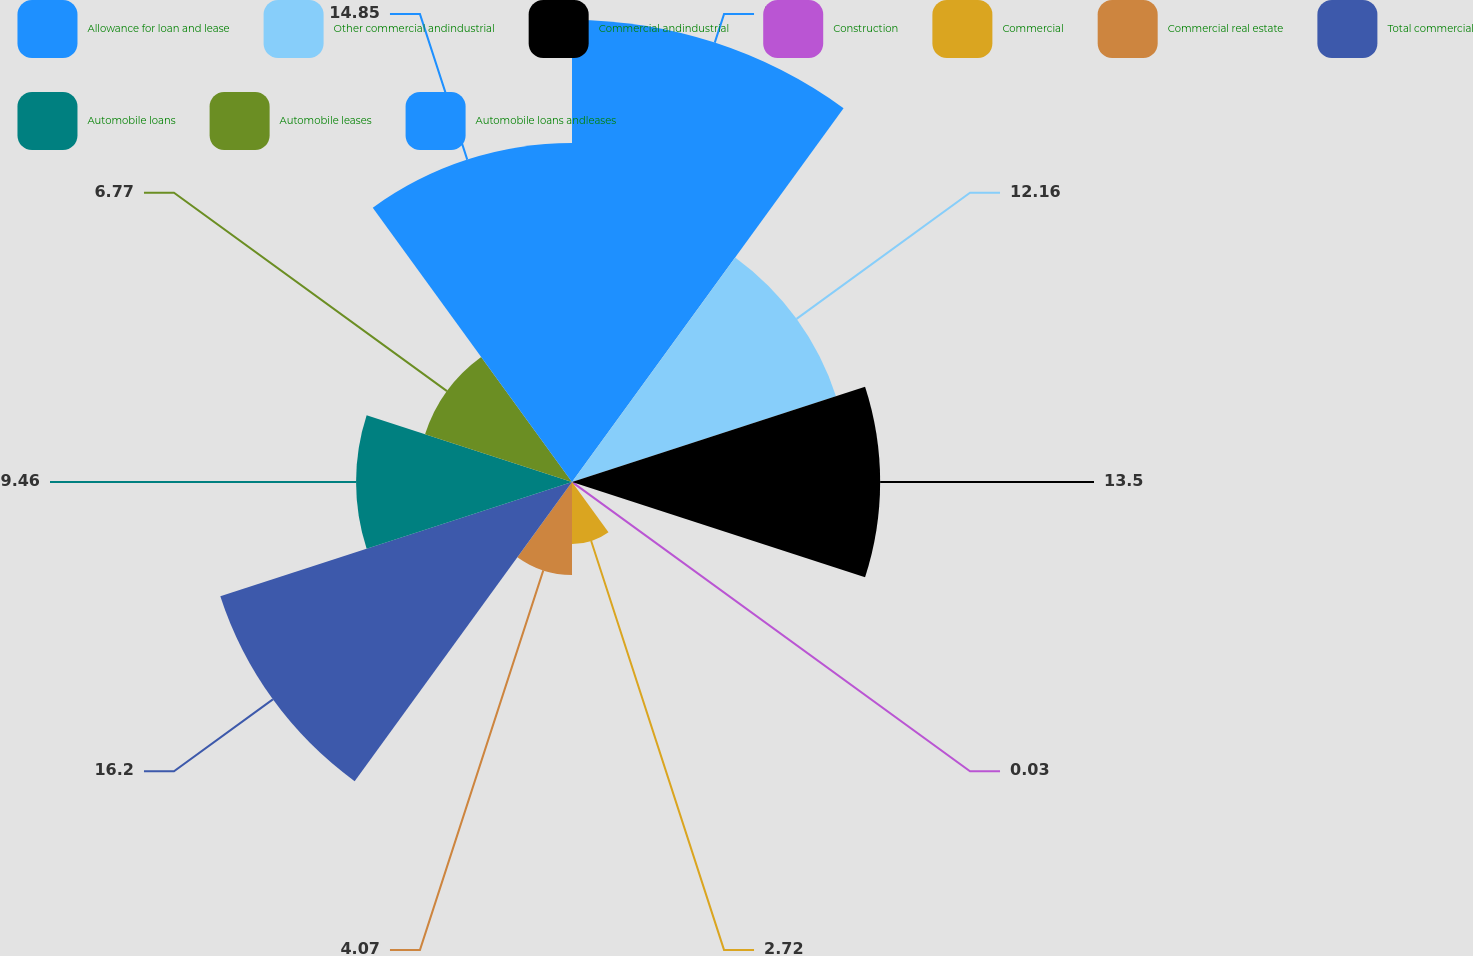Convert chart to OTSL. <chart><loc_0><loc_0><loc_500><loc_500><pie_chart><fcel>Allowance for loan and lease<fcel>Other commercial andindustrial<fcel>Commercial andindustrial<fcel>Construction<fcel>Commercial<fcel>Commercial real estate<fcel>Total commercial<fcel>Automobile loans<fcel>Automobile leases<fcel>Automobile loans andleases<nl><fcel>20.24%<fcel>12.16%<fcel>13.5%<fcel>0.03%<fcel>2.72%<fcel>4.07%<fcel>16.2%<fcel>9.46%<fcel>6.77%<fcel>14.85%<nl></chart> 